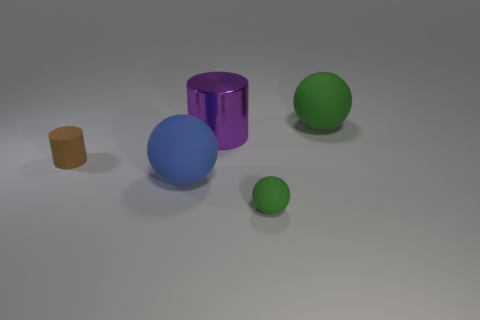What size is the thing that is the same color as the tiny rubber ball?
Your response must be concise. Large. Do the purple cylinder and the brown cylinder have the same size?
Offer a terse response. No. What number of objects are small cyan blocks or small brown things that are on the left side of the purple shiny cylinder?
Provide a short and direct response. 1. There is a large rubber thing that is on the left side of the green rubber sphere that is behind the small matte ball; what is its color?
Ensure brevity in your answer.  Blue. There is a big sphere behind the purple cylinder; is it the same color as the tiny ball?
Offer a terse response. Yes. What material is the large object that is left of the large shiny cylinder?
Your answer should be very brief. Rubber. The purple metallic cylinder is what size?
Offer a very short reply. Large. Are the tiny object in front of the brown cylinder and the large cylinder made of the same material?
Your answer should be very brief. No. How many large green rubber things are there?
Make the answer very short. 1. What number of objects are red objects or blue matte spheres?
Offer a terse response. 1. 